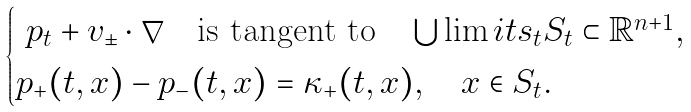Convert formula to latex. <formula><loc_0><loc_0><loc_500><loc_500>\begin{cases} \ p _ { t } + v _ { \pm } \cdot \nabla \quad \text {is tangent to} \quad \bigcup \lim i t s _ { t } S _ { t } \subset \mathbb { R } ^ { n + 1 } , \\ p _ { + } ( t , x ) - p _ { - } ( t , x ) = \kappa _ { + } ( t , x ) , \quad x \in S _ { t } . \end{cases}</formula> 